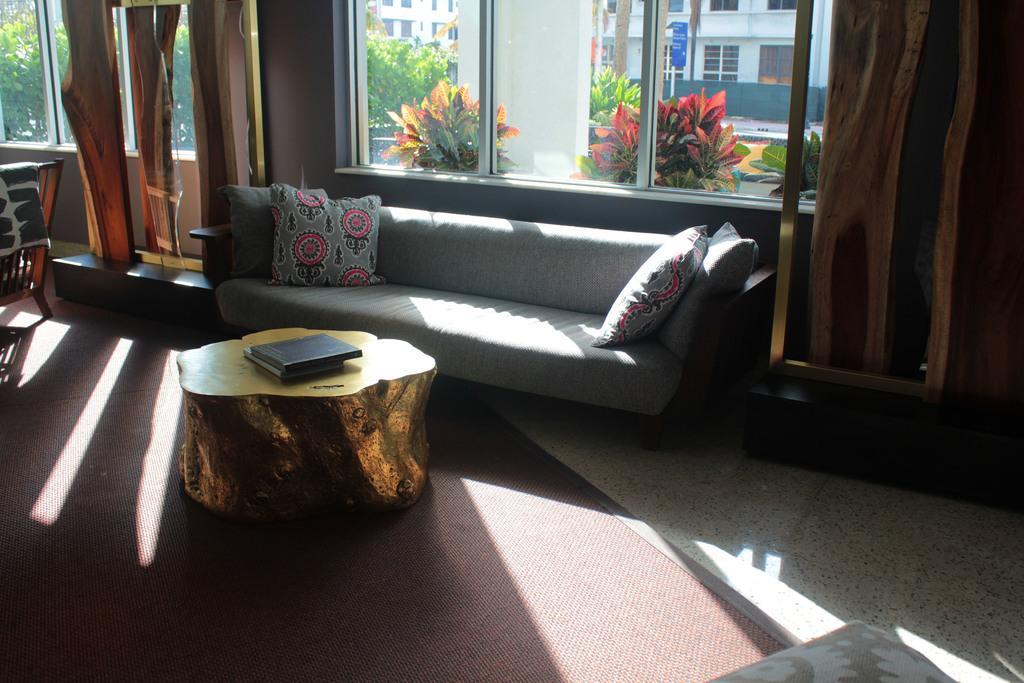Can you describe this image briefly? The image is inside the room. In the image in middle of the room there is a couch, on couch we can see four pillows which is placed behind the table. On table we can see few books and on left side there is a chair with some clothes and a window which is closed ,curtains,trees. In background there are some trees,plants,pillar,windows,hoardings and a building. 